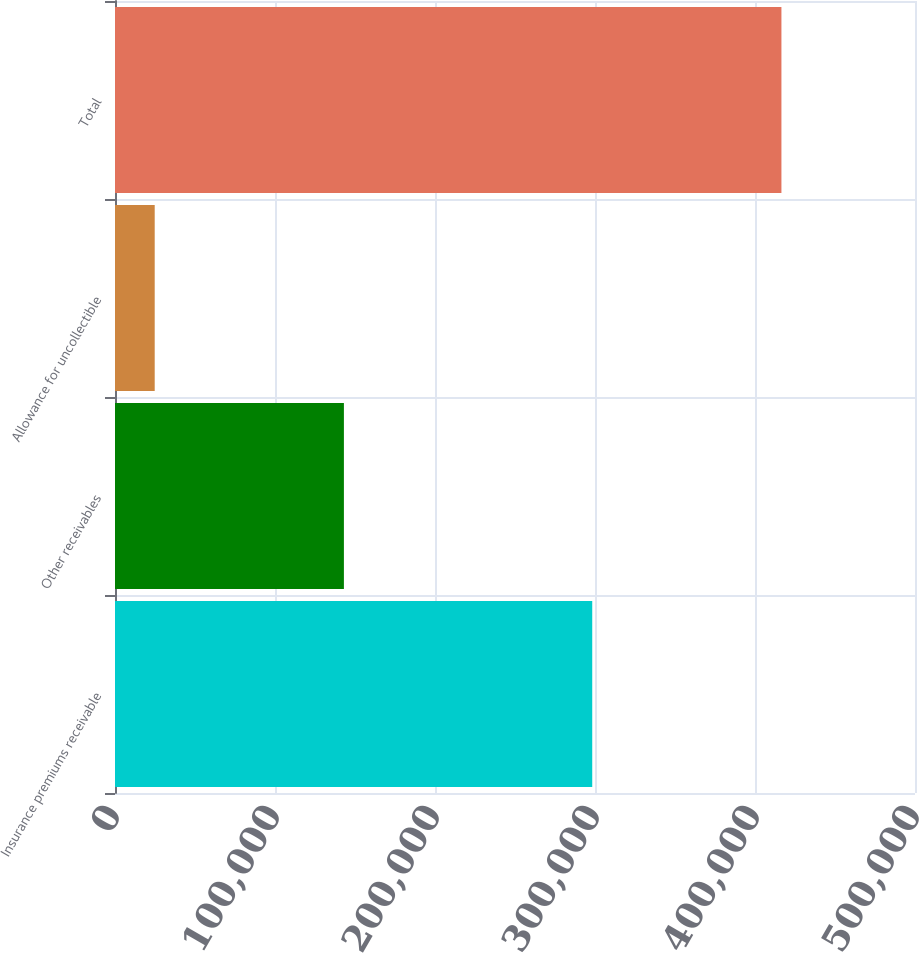Convert chart to OTSL. <chart><loc_0><loc_0><loc_500><loc_500><bar_chart><fcel>Insurance premiums receivable<fcel>Other receivables<fcel>Allowance for uncollectible<fcel>Total<nl><fcel>298271<fcel>143064<fcel>24818<fcel>416517<nl></chart> 